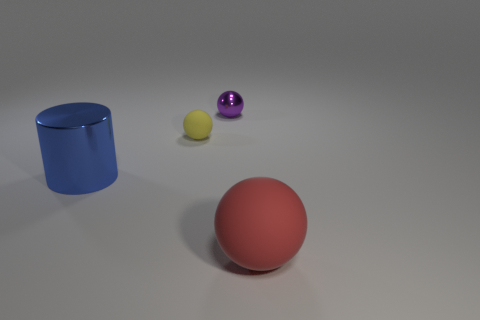There is a large object that is on the right side of the metal cylinder; is it the same shape as the tiny matte object?
Keep it short and to the point. Yes. Are there more tiny shiny spheres on the right side of the tiny shiny thing than shiny cylinders?
Your answer should be very brief. No. There is a rubber object behind the large object that is to the right of the big metal thing; what color is it?
Offer a very short reply. Yellow. What number of blue shiny objects are there?
Keep it short and to the point. 1. How many objects are both in front of the yellow rubber ball and to the left of the small purple thing?
Ensure brevity in your answer.  1. Are there any other things that are the same shape as the big metallic object?
Provide a succinct answer. No. There is a metallic sphere; is it the same color as the thing to the left of the tiny rubber ball?
Offer a very short reply. No. There is a metal thing that is behind the blue metallic cylinder; what shape is it?
Ensure brevity in your answer.  Sphere. How many other things are there of the same material as the small yellow object?
Give a very brief answer. 1. What material is the small yellow ball?
Provide a succinct answer. Rubber. 